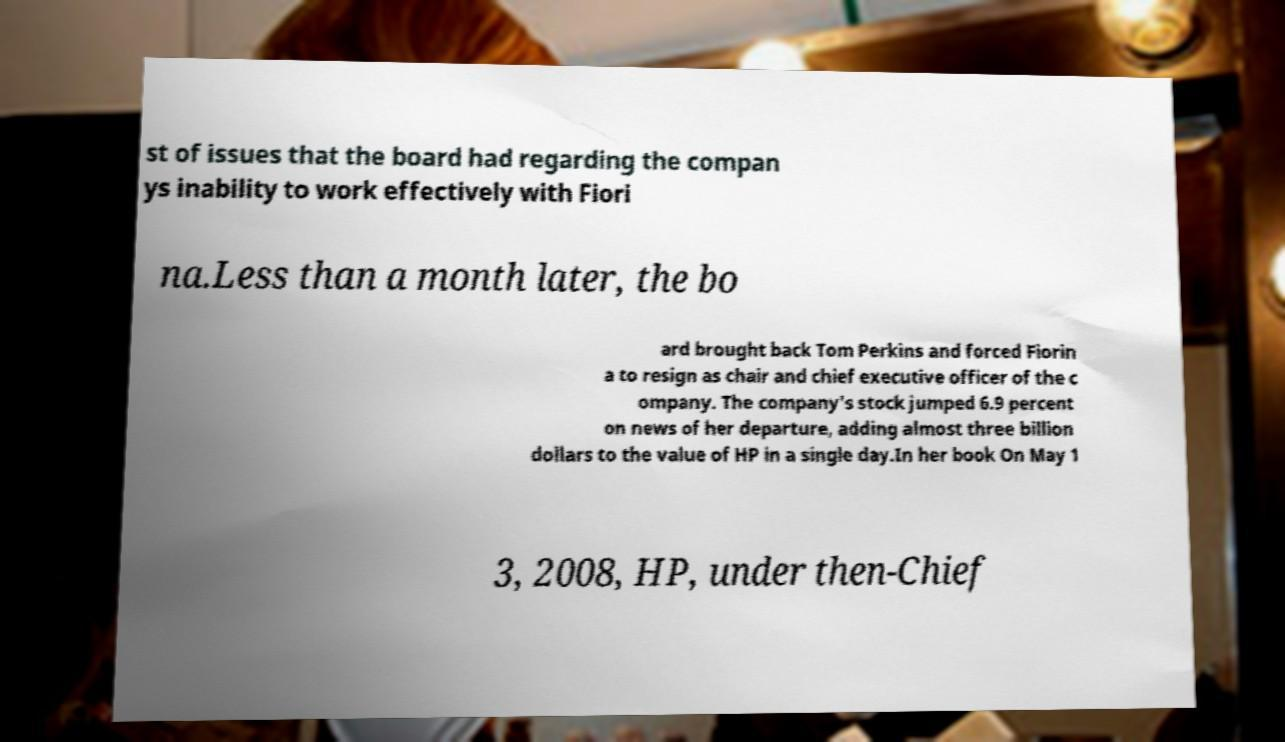For documentation purposes, I need the text within this image transcribed. Could you provide that? st of issues that the board had regarding the compan ys inability to work effectively with Fiori na.Less than a month later, the bo ard brought back Tom Perkins and forced Fiorin a to resign as chair and chief executive officer of the c ompany. The company's stock jumped 6.9 percent on news of her departure, adding almost three billion dollars to the value of HP in a single day.In her book On May 1 3, 2008, HP, under then-Chief 